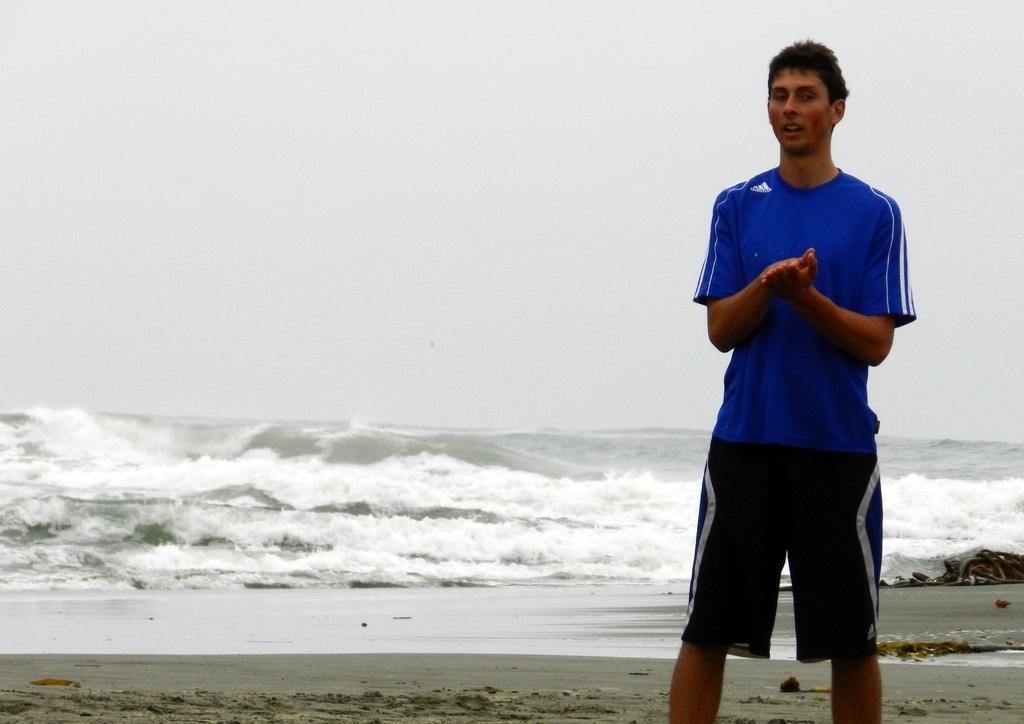Please provide a concise description of this image. On the right a man is standing and there is an object on the sand. In the background we can see sand,water and the sky. 